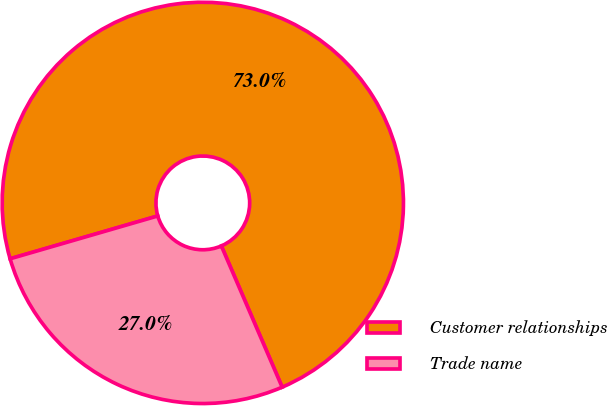<chart> <loc_0><loc_0><loc_500><loc_500><pie_chart><fcel>Customer relationships<fcel>Trade name<nl><fcel>73.02%<fcel>26.98%<nl></chart> 